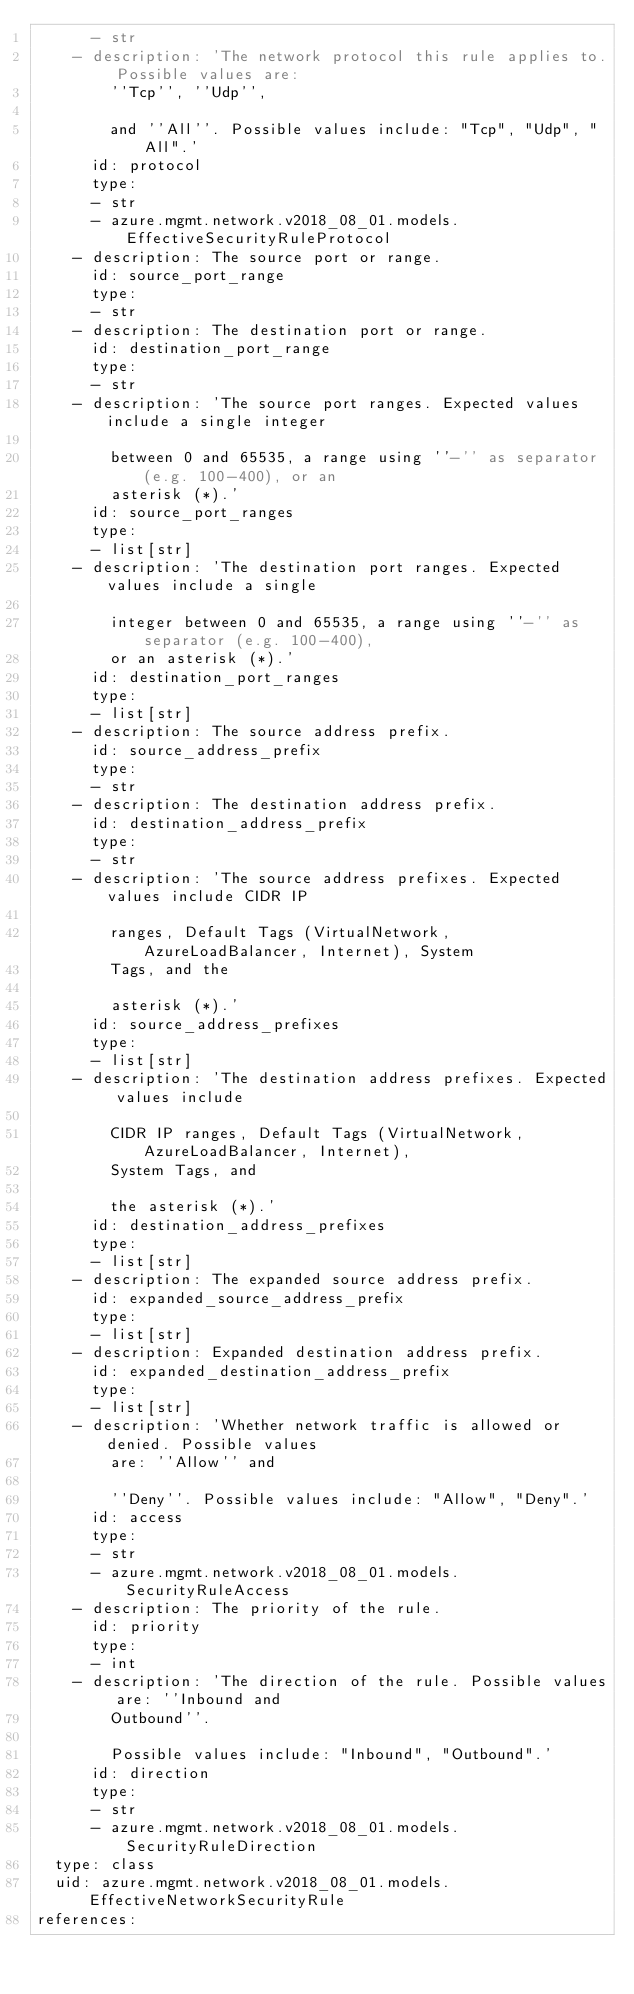<code> <loc_0><loc_0><loc_500><loc_500><_YAML_>      - str
    - description: 'The network protocol this rule applies to. Possible values are:
        ''Tcp'', ''Udp'',

        and ''All''. Possible values include: "Tcp", "Udp", "All".'
      id: protocol
      type:
      - str
      - azure.mgmt.network.v2018_08_01.models.EffectiveSecurityRuleProtocol
    - description: The source port or range.
      id: source_port_range
      type:
      - str
    - description: The destination port or range.
      id: destination_port_range
      type:
      - str
    - description: 'The source port ranges. Expected values include a single integer

        between 0 and 65535, a range using ''-'' as separator (e.g. 100-400), or an
        asterisk (*).'
      id: source_port_ranges
      type:
      - list[str]
    - description: 'The destination port ranges. Expected values include a single

        integer between 0 and 65535, a range using ''-'' as separator (e.g. 100-400),
        or an asterisk (*).'
      id: destination_port_ranges
      type:
      - list[str]
    - description: The source address prefix.
      id: source_address_prefix
      type:
      - str
    - description: The destination address prefix.
      id: destination_address_prefix
      type:
      - str
    - description: 'The source address prefixes. Expected values include CIDR IP

        ranges, Default Tags (VirtualNetwork, AzureLoadBalancer, Internet), System
        Tags, and the

        asterisk (*).'
      id: source_address_prefixes
      type:
      - list[str]
    - description: 'The destination address prefixes. Expected values include

        CIDR IP ranges, Default Tags (VirtualNetwork, AzureLoadBalancer, Internet),
        System Tags, and

        the asterisk (*).'
      id: destination_address_prefixes
      type:
      - list[str]
    - description: The expanded source address prefix.
      id: expanded_source_address_prefix
      type:
      - list[str]
    - description: Expanded destination address prefix.
      id: expanded_destination_address_prefix
      type:
      - list[str]
    - description: 'Whether network traffic is allowed or denied. Possible values
        are: ''Allow'' and

        ''Deny''. Possible values include: "Allow", "Deny".'
      id: access
      type:
      - str
      - azure.mgmt.network.v2018_08_01.models.SecurityRuleAccess
    - description: The priority of the rule.
      id: priority
      type:
      - int
    - description: 'The direction of the rule. Possible values are: ''Inbound and
        Outbound''.

        Possible values include: "Inbound", "Outbound".'
      id: direction
      type:
      - str
      - azure.mgmt.network.v2018_08_01.models.SecurityRuleDirection
  type: class
  uid: azure.mgmt.network.v2018_08_01.models.EffectiveNetworkSecurityRule
references:</code> 